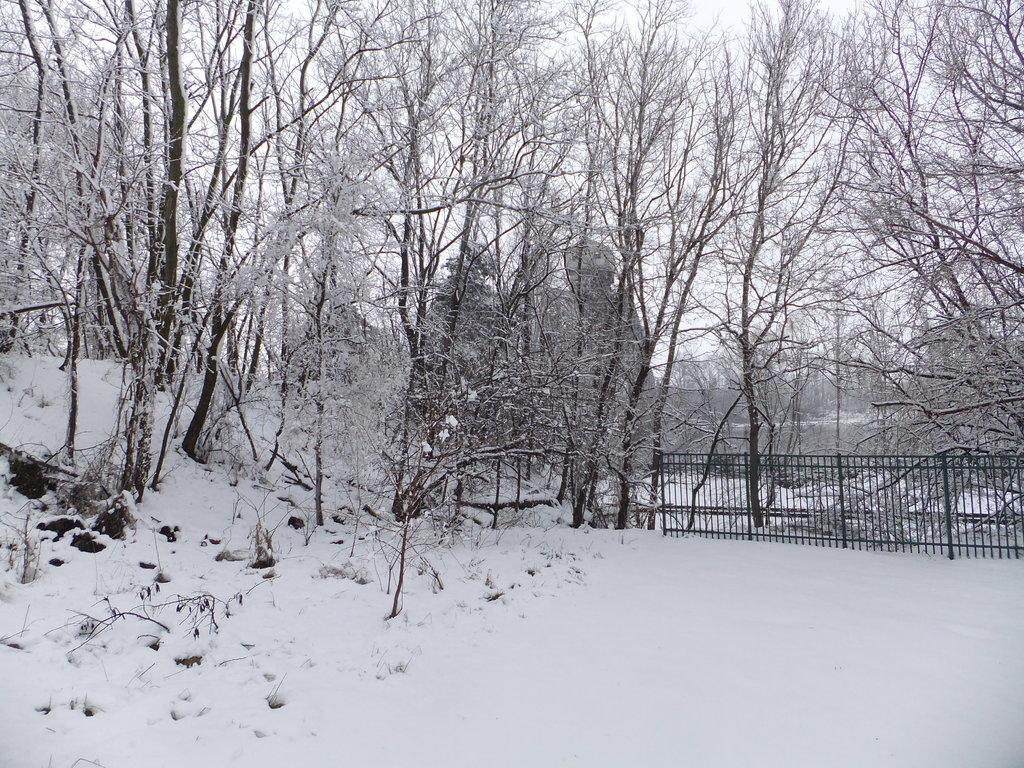What type of vegetation can be seen in the image? There are trees in the image. What structure is present in the image? There is a fence in the image. What is the weather like in the image? The snow visible in the image suggests a cold or wintry weather. What can be seen in the background of the image? The sky is visible in the background of the image. What type of wine is being served in the image? There is no wine present in the image; it features trees, a fence, snow, and the sky. What kind of flower is blooming near the fence in the image? There is no flower present in the image; it only features trees, a fence, snow, and the sky. 